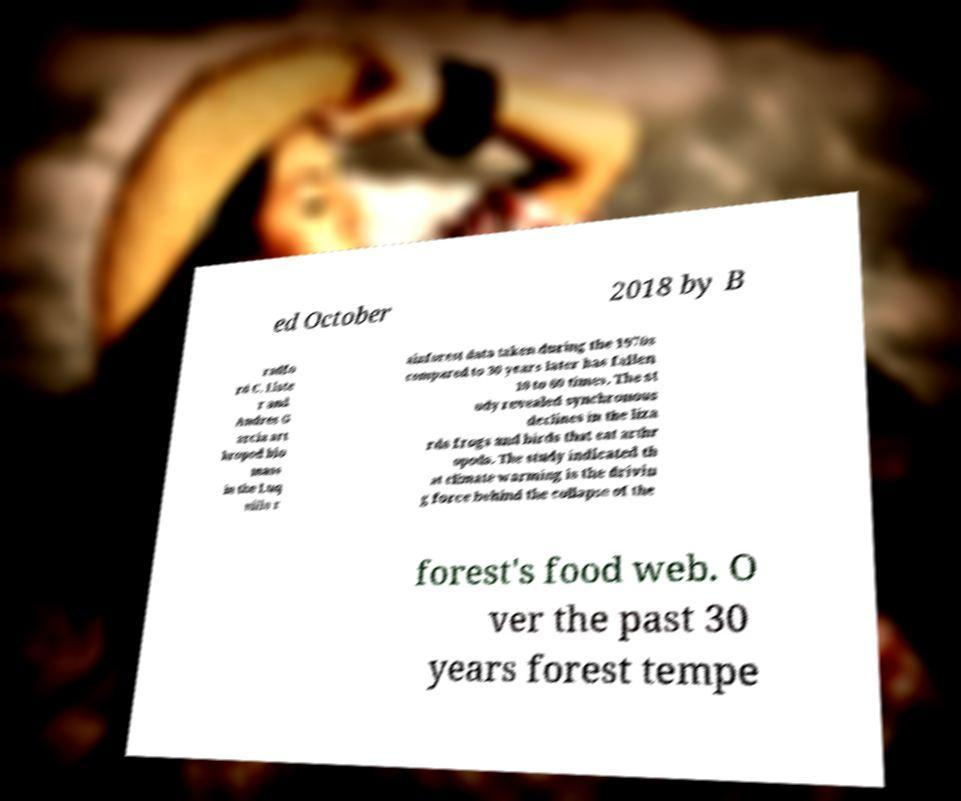What messages or text are displayed in this image? I need them in a readable, typed format. ed October 2018 by B radfo rd C. Liste r and Andres G arcia art hropod bio mass in the Luq uillo r ainforest data taken during the 1970s compared to 30 years later has fallen 10 to 60 times. The st udy revealed synchronous declines in the liza rds frogs and birds that eat arthr opods. The study indicated th at climate warming is the drivin g force behind the collapse of the forest's food web. O ver the past 30 years forest tempe 